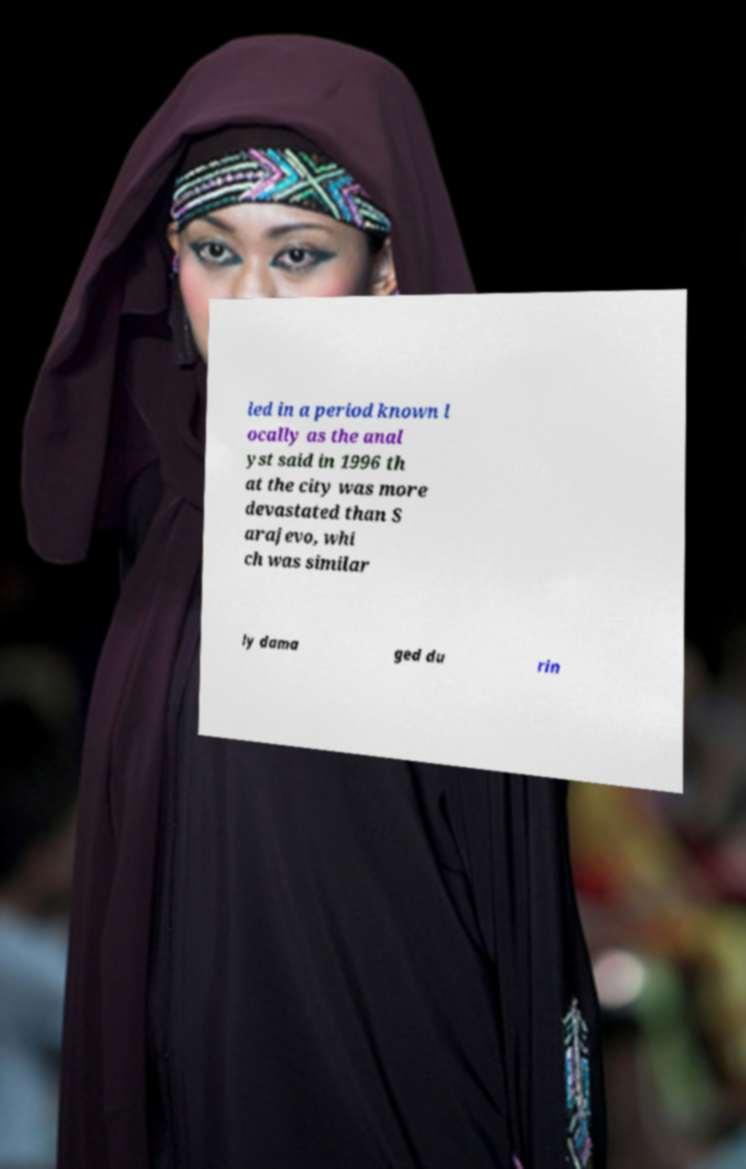I need the written content from this picture converted into text. Can you do that? led in a period known l ocally as the anal yst said in 1996 th at the city was more devastated than S arajevo, whi ch was similar ly dama ged du rin 